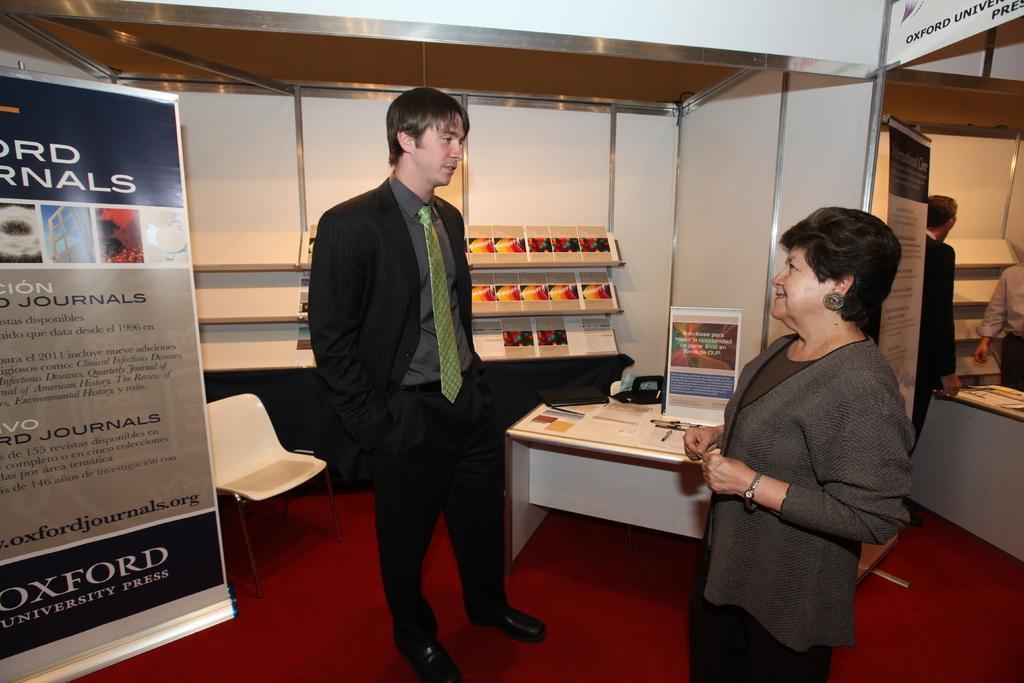Describe this image in one or two sentences. In the image we can see there is a man who is standing and he is looking at a woman and even she is standing and on the table we can see there is a cardboard sheet and at the back there is a shelf in which books are kept. 